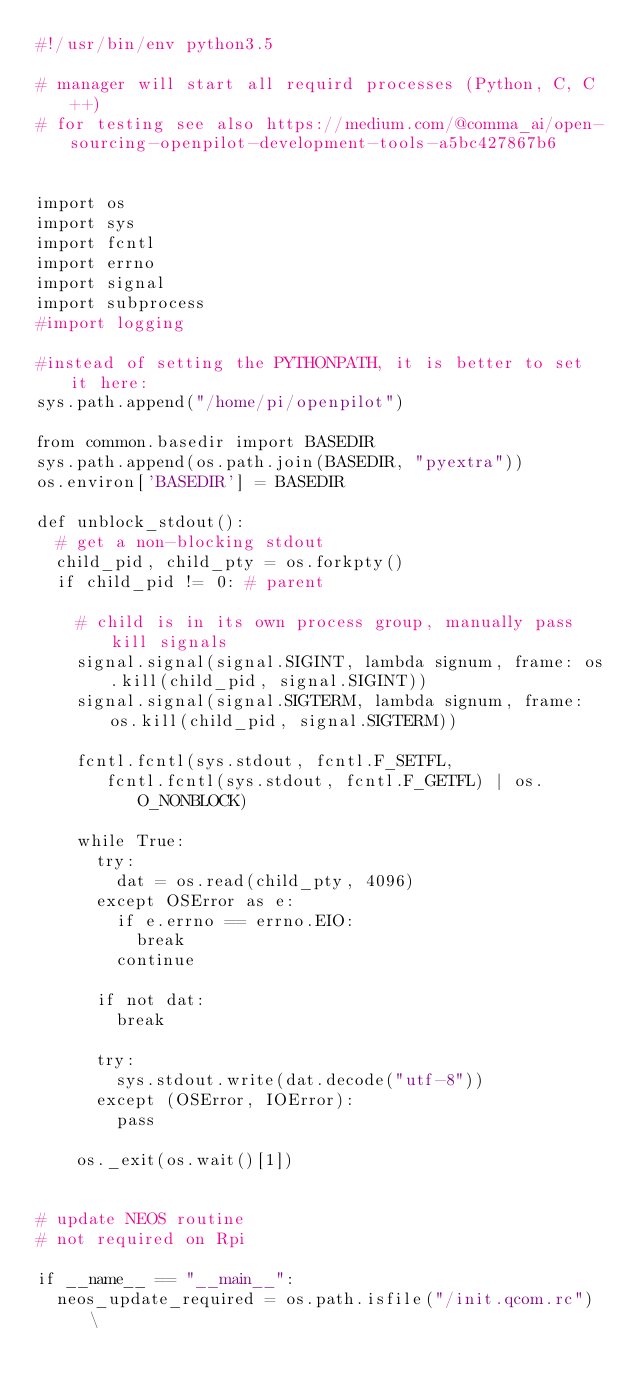Convert code to text. <code><loc_0><loc_0><loc_500><loc_500><_Python_>#!/usr/bin/env python3.5

# manager will start all requird processes (Python, C, C++)
# for testing see also https://medium.com/@comma_ai/open-sourcing-openpilot-development-tools-a5bc427867b6


import os
import sys
import fcntl
import errno
import signal
import subprocess
#import logging

#instead of setting the PYTHONPATH, it is better to set it here:
sys.path.append("/home/pi/openpilot")

from common.basedir import BASEDIR
sys.path.append(os.path.join(BASEDIR, "pyextra"))
os.environ['BASEDIR'] = BASEDIR

def unblock_stdout():
  # get a non-blocking stdout
  child_pid, child_pty = os.forkpty()
  if child_pid != 0: # parent

    # child is in its own process group, manually pass kill signals
    signal.signal(signal.SIGINT, lambda signum, frame: os.kill(child_pid, signal.SIGINT))
    signal.signal(signal.SIGTERM, lambda signum, frame: os.kill(child_pid, signal.SIGTERM))

    fcntl.fcntl(sys.stdout, fcntl.F_SETFL,
       fcntl.fcntl(sys.stdout, fcntl.F_GETFL) | os.O_NONBLOCK)

    while True:
      try:
        dat = os.read(child_pty, 4096)
      except OSError as e:
        if e.errno == errno.EIO:
          break
        continue

      if not dat:
        break

      try:
        sys.stdout.write(dat.decode("utf-8"))
      except (OSError, IOError):
        pass

    os._exit(os.wait()[1])


# update NEOS routine
# not required on Rpi

if __name__ == "__main__":
  neos_update_required = os.path.isfile("/init.qcom.rc") \</code> 